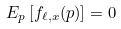Convert formula to latex. <formula><loc_0><loc_0><loc_500><loc_500>E _ { p } \left [ f _ { \ell , x } ( p ) \right ] = 0</formula> 